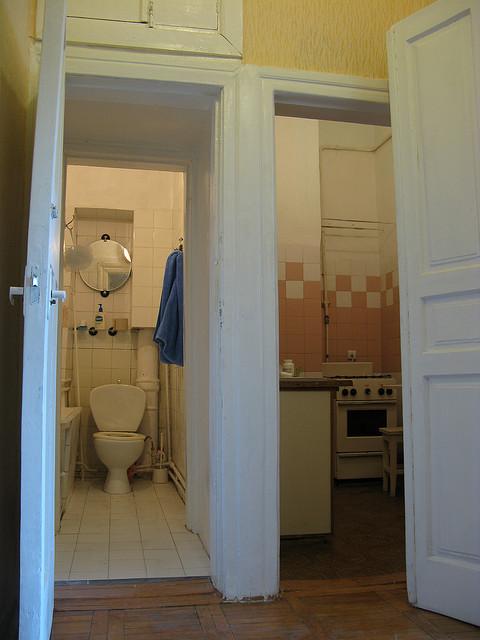What type of wood is on the floor?
Keep it brief. Hardwood. Is the images of the same bathroom?
Answer briefly. No. How many locks are on the door?
Answer briefly. 1. Is there a stove in this photo?
Short answer required. Yes. Which door dispenses water?
Give a very brief answer. Left. What is beside the bathroom?
Keep it brief. Kitchen. Is there a mirror?
Answer briefly. Yes. 